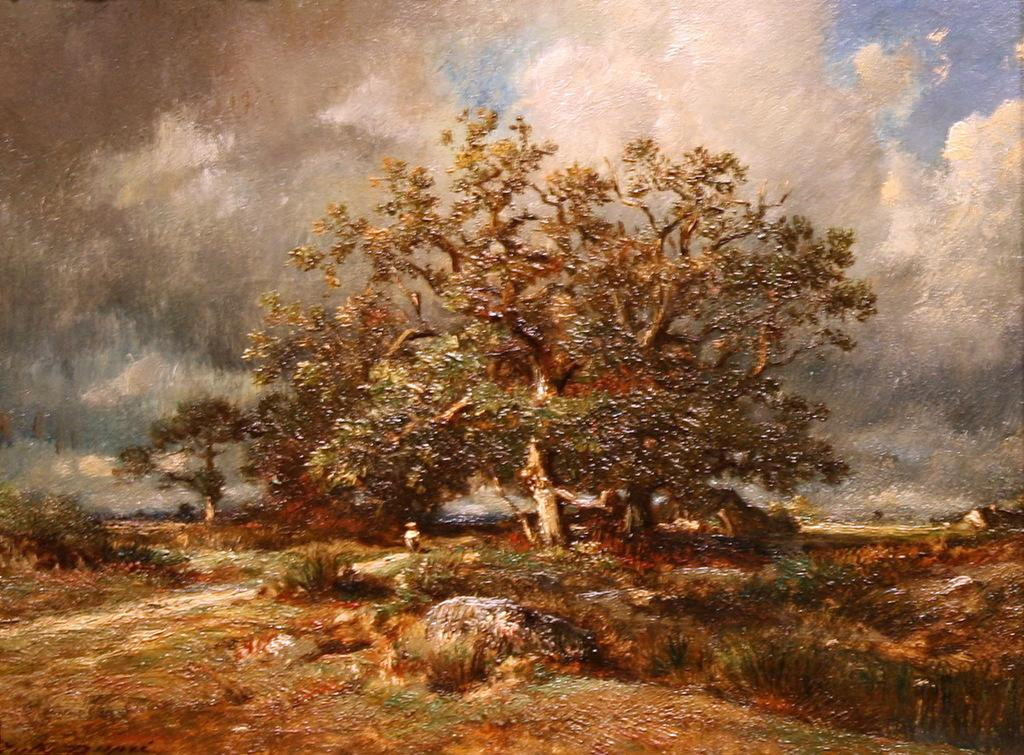What type of vegetation can be seen in the image? There are trees and plants in the image. What part of the natural element is visible in the background of the image? The sky is visible in the background of the image. How do the clouds in the sky appear? The clouds in the sky appear heavy. What type of bread can be seen on the roof in the image? There is no bread or roof present in the image; it features trees, plants, and a sky with heavy clouds. 